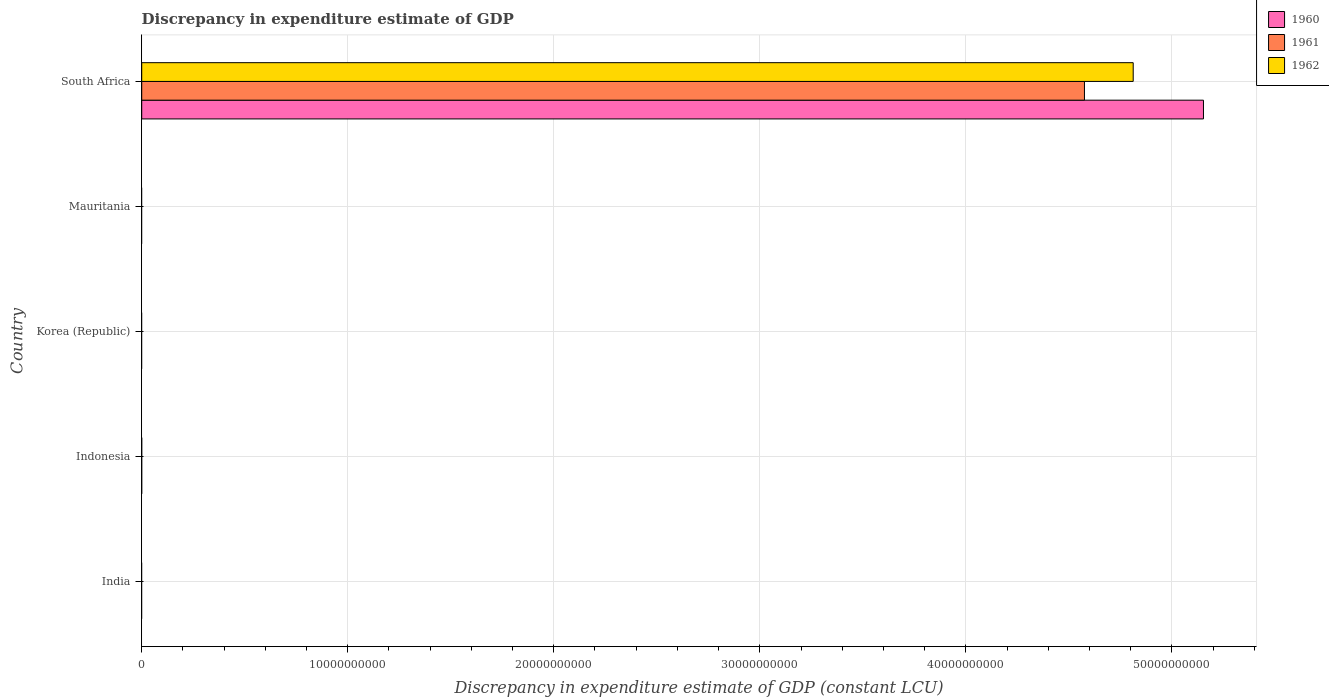How many different coloured bars are there?
Ensure brevity in your answer.  3. Are the number of bars per tick equal to the number of legend labels?
Your answer should be very brief. No. Are the number of bars on each tick of the Y-axis equal?
Give a very brief answer. No. How many bars are there on the 1st tick from the top?
Your answer should be very brief. 3. How many bars are there on the 2nd tick from the bottom?
Provide a short and direct response. 0. What is the label of the 2nd group of bars from the top?
Your response must be concise. Mauritania. What is the discrepancy in expenditure estimate of GDP in 1960 in Korea (Republic)?
Provide a succinct answer. 0. Across all countries, what is the maximum discrepancy in expenditure estimate of GDP in 1962?
Keep it short and to the point. 4.81e+1. Across all countries, what is the minimum discrepancy in expenditure estimate of GDP in 1962?
Provide a short and direct response. 0. In which country was the discrepancy in expenditure estimate of GDP in 1960 maximum?
Make the answer very short. South Africa. What is the total discrepancy in expenditure estimate of GDP in 1962 in the graph?
Your response must be concise. 4.81e+1. What is the difference between the discrepancy in expenditure estimate of GDP in 1962 in South Africa and the discrepancy in expenditure estimate of GDP in 1961 in Korea (Republic)?
Your response must be concise. 4.81e+1. What is the average discrepancy in expenditure estimate of GDP in 1961 per country?
Offer a terse response. 9.15e+09. What is the difference between the discrepancy in expenditure estimate of GDP in 1962 and discrepancy in expenditure estimate of GDP in 1961 in South Africa?
Provide a short and direct response. 2.37e+09. In how many countries, is the discrepancy in expenditure estimate of GDP in 1961 greater than 24000000000 LCU?
Provide a succinct answer. 1. What is the difference between the highest and the lowest discrepancy in expenditure estimate of GDP in 1962?
Keep it short and to the point. 4.81e+1. In how many countries, is the discrepancy in expenditure estimate of GDP in 1961 greater than the average discrepancy in expenditure estimate of GDP in 1961 taken over all countries?
Provide a succinct answer. 1. Is it the case that in every country, the sum of the discrepancy in expenditure estimate of GDP in 1960 and discrepancy in expenditure estimate of GDP in 1961 is greater than the discrepancy in expenditure estimate of GDP in 1962?
Keep it short and to the point. No. How many bars are there?
Make the answer very short. 3. Are all the bars in the graph horizontal?
Offer a terse response. Yes. How many countries are there in the graph?
Provide a succinct answer. 5. What is the difference between two consecutive major ticks on the X-axis?
Give a very brief answer. 1.00e+1. Are the values on the major ticks of X-axis written in scientific E-notation?
Keep it short and to the point. No. Does the graph contain any zero values?
Offer a terse response. Yes. Does the graph contain grids?
Your answer should be compact. Yes. How many legend labels are there?
Your response must be concise. 3. How are the legend labels stacked?
Your answer should be compact. Vertical. What is the title of the graph?
Ensure brevity in your answer.  Discrepancy in expenditure estimate of GDP. What is the label or title of the X-axis?
Offer a very short reply. Discrepancy in expenditure estimate of GDP (constant LCU). What is the label or title of the Y-axis?
Keep it short and to the point. Country. What is the Discrepancy in expenditure estimate of GDP (constant LCU) of 1962 in India?
Provide a short and direct response. 0. What is the Discrepancy in expenditure estimate of GDP (constant LCU) in 1960 in Indonesia?
Make the answer very short. 0. What is the Discrepancy in expenditure estimate of GDP (constant LCU) of 1962 in Indonesia?
Provide a short and direct response. 0. What is the Discrepancy in expenditure estimate of GDP (constant LCU) in 1960 in Korea (Republic)?
Ensure brevity in your answer.  0. What is the Discrepancy in expenditure estimate of GDP (constant LCU) of 1962 in Korea (Republic)?
Offer a very short reply. 0. What is the Discrepancy in expenditure estimate of GDP (constant LCU) in 1961 in Mauritania?
Offer a very short reply. 0. What is the Discrepancy in expenditure estimate of GDP (constant LCU) of 1960 in South Africa?
Ensure brevity in your answer.  5.15e+1. What is the Discrepancy in expenditure estimate of GDP (constant LCU) in 1961 in South Africa?
Make the answer very short. 4.58e+1. What is the Discrepancy in expenditure estimate of GDP (constant LCU) in 1962 in South Africa?
Provide a succinct answer. 4.81e+1. Across all countries, what is the maximum Discrepancy in expenditure estimate of GDP (constant LCU) in 1960?
Offer a very short reply. 5.15e+1. Across all countries, what is the maximum Discrepancy in expenditure estimate of GDP (constant LCU) in 1961?
Your answer should be compact. 4.58e+1. Across all countries, what is the maximum Discrepancy in expenditure estimate of GDP (constant LCU) in 1962?
Give a very brief answer. 4.81e+1. Across all countries, what is the minimum Discrepancy in expenditure estimate of GDP (constant LCU) of 1962?
Give a very brief answer. 0. What is the total Discrepancy in expenditure estimate of GDP (constant LCU) in 1960 in the graph?
Give a very brief answer. 5.15e+1. What is the total Discrepancy in expenditure estimate of GDP (constant LCU) in 1961 in the graph?
Give a very brief answer. 4.58e+1. What is the total Discrepancy in expenditure estimate of GDP (constant LCU) of 1962 in the graph?
Provide a short and direct response. 4.81e+1. What is the average Discrepancy in expenditure estimate of GDP (constant LCU) of 1960 per country?
Give a very brief answer. 1.03e+1. What is the average Discrepancy in expenditure estimate of GDP (constant LCU) in 1961 per country?
Give a very brief answer. 9.15e+09. What is the average Discrepancy in expenditure estimate of GDP (constant LCU) of 1962 per country?
Your answer should be compact. 9.62e+09. What is the difference between the Discrepancy in expenditure estimate of GDP (constant LCU) of 1960 and Discrepancy in expenditure estimate of GDP (constant LCU) of 1961 in South Africa?
Your response must be concise. 5.78e+09. What is the difference between the Discrepancy in expenditure estimate of GDP (constant LCU) of 1960 and Discrepancy in expenditure estimate of GDP (constant LCU) of 1962 in South Africa?
Ensure brevity in your answer.  3.41e+09. What is the difference between the Discrepancy in expenditure estimate of GDP (constant LCU) of 1961 and Discrepancy in expenditure estimate of GDP (constant LCU) of 1962 in South Africa?
Your answer should be very brief. -2.37e+09. What is the difference between the highest and the lowest Discrepancy in expenditure estimate of GDP (constant LCU) in 1960?
Offer a terse response. 5.15e+1. What is the difference between the highest and the lowest Discrepancy in expenditure estimate of GDP (constant LCU) in 1961?
Provide a succinct answer. 4.58e+1. What is the difference between the highest and the lowest Discrepancy in expenditure estimate of GDP (constant LCU) in 1962?
Give a very brief answer. 4.81e+1. 